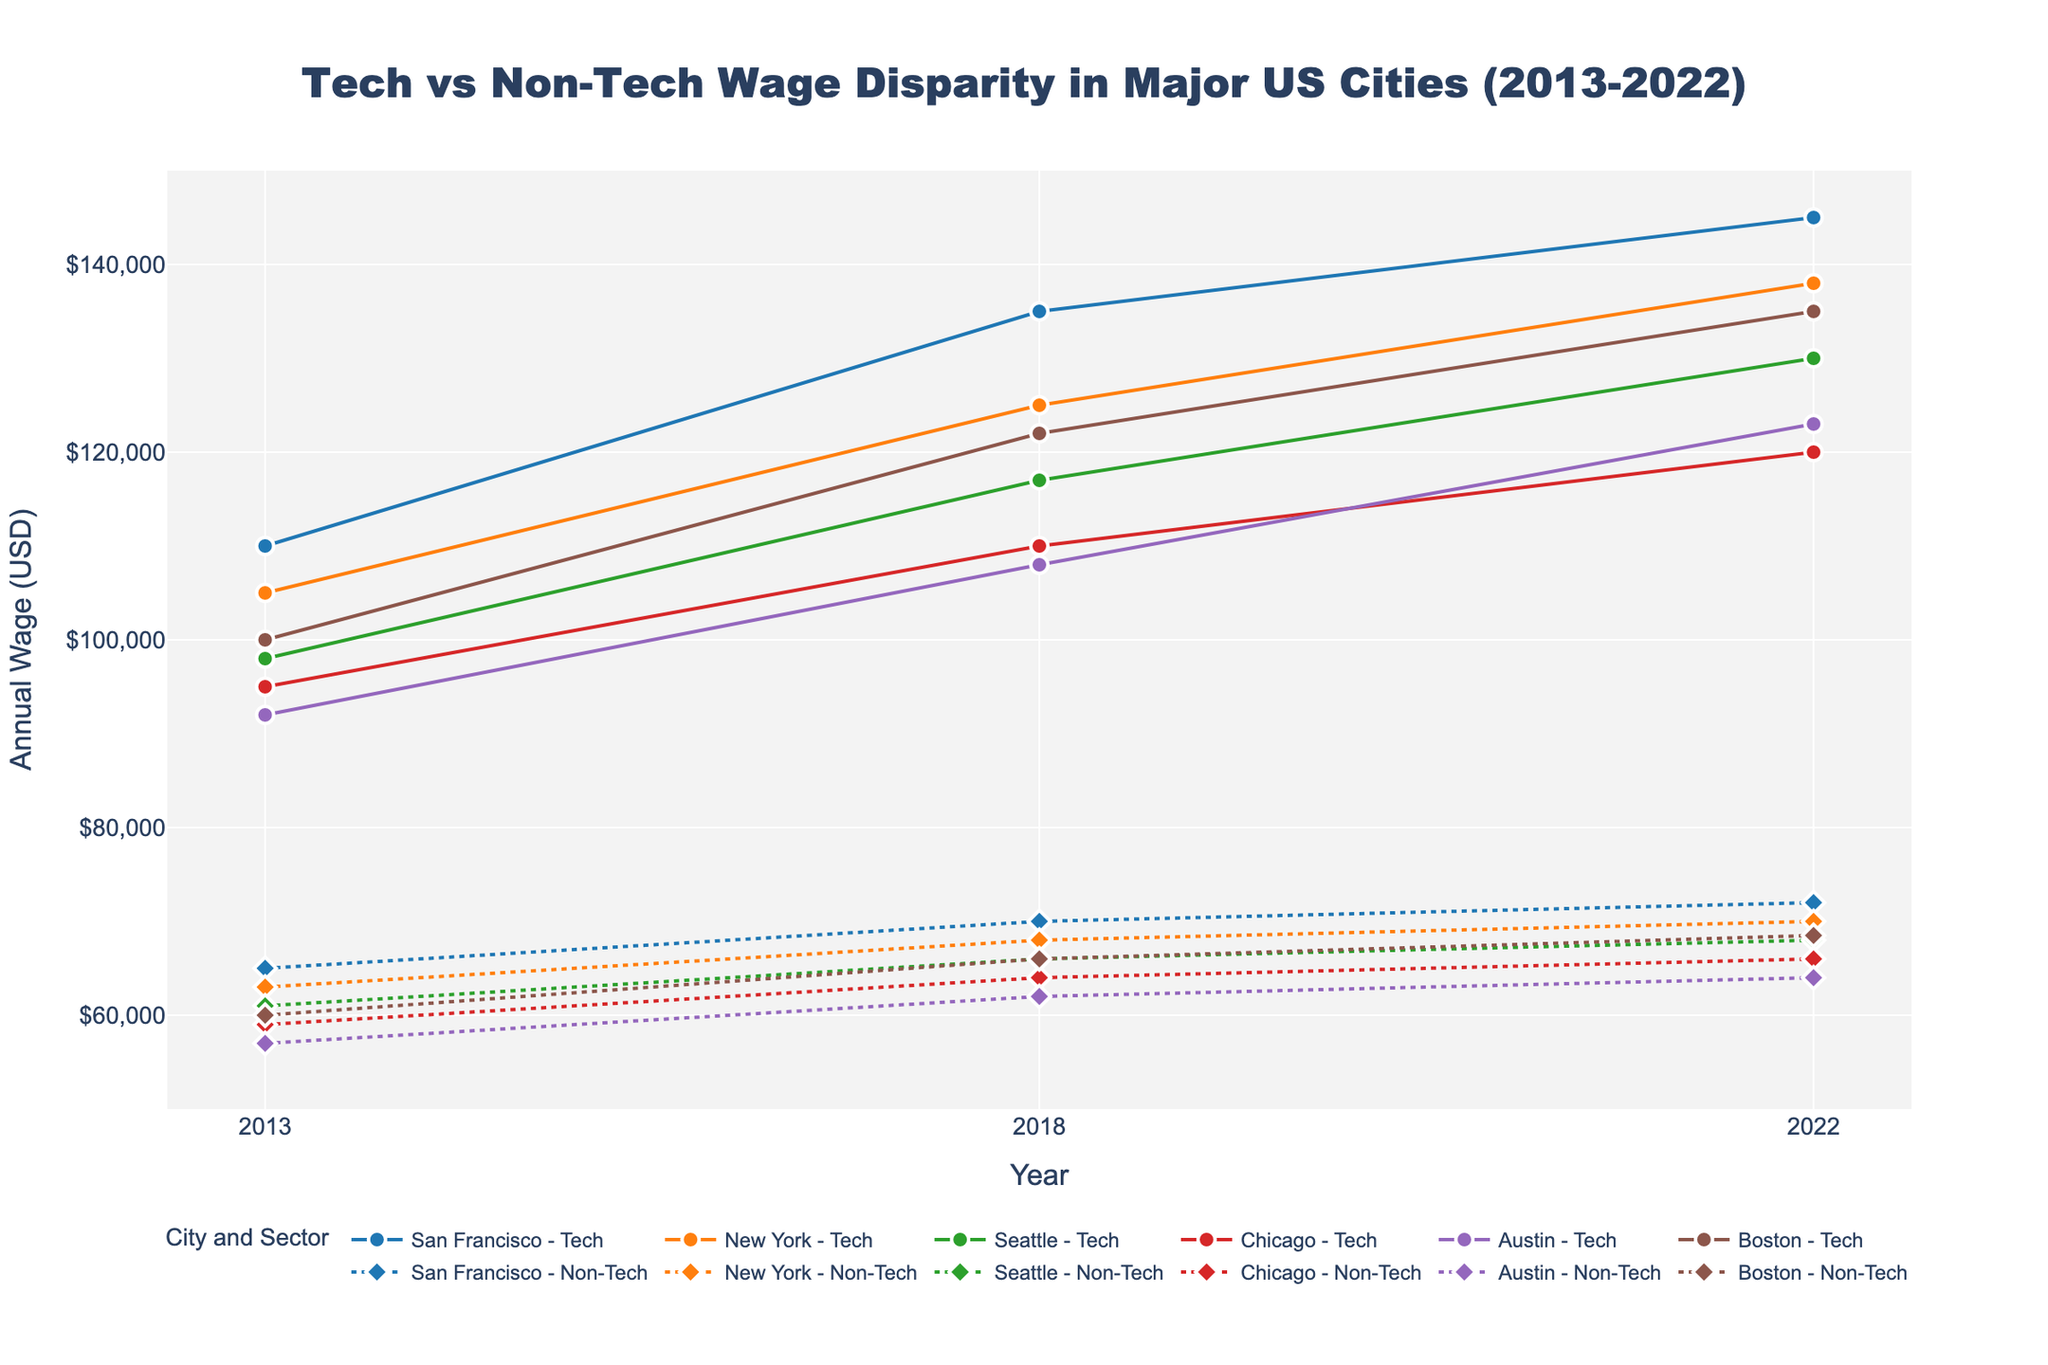What's the title of the figure? The title of the figure is displayed at the top of the plot, usually in larger or bold font.
Answer: Tech vs Non-Tech Wage Disparity in Major US Cities (2013-2022) Which city shows the highest tech wage in 2022? By observing the plot for the year 2022, identify the city with the highest marker in the tech wage line.
Answer: San Francisco What is the difference in tech wages in New York between 2013 and 2022? Locate the tech wage data points for New York in 2013 and 2022 and calculate their difference. New York's tech wages are $105,000 in 2013 and $138,000 in 2022. The difference is $138,000 - $105,000.
Answer: $33,000 Which year shows the smallest disparity between tech and non-tech wages in Chicago? Compare tech and non-tech wage lines for Chicago across all years. The smallest disparity occurs when the tech and non-tech wages are closest.
Answer: 2022 How much did the tech wage in San Francisco increase from 2013 to 2018? Locate the tech wage data points for San Francisco in 2013 and 2018, then calculate the increase: $135,000 (2018) - $110,000 (2013).
Answer: $25,000 In which year across the dataset do we observe the largest disparity between tech and non-tech wages for any city? Scan all years and cities to find the largest vertical gap between tech and non-tech wage markers, which indicates the largest disparity.
Answer: 2022 in San Francisco Compare the tech wage trends from 2013 to 2022 between Seattle and Boston. Observe the lines for tech wages in Seattle and Boston over the years. Both cities show tech wage growth, but Boston starts higher and ends higher than Seattle, though both show accelerating trends.
Answer: Boston maintains higher but accelerating trends Identify the city with the smallest increase in non-tech wages between 2013 and 2022. Calculate the difference in non-tech wages for each city between 2013 and 2022 and identify the smallest value. San Francisco has non-tech wages of $65,000 in 2013 and $72,000 in 2022, the increase is $7,000.
Answer: San Francisco What is the average tech wage in Austin across the three recorded years? Sum the tech wages of Austin for 2013 ($92,000), 2018 ($108,000), and 2022 ($123,000) and divide by 3.
Answer: $107,667 Which city shows the smallest disparity in wages (tech vs. non-tech) in the year 2018? For the year 2018, compare the wage disparities (tech - non-tech) for all cities and find the smallest value. The disparity for Austin in 2018 is $108,000 - $62,000 = $46,000.
Answer: Austin 